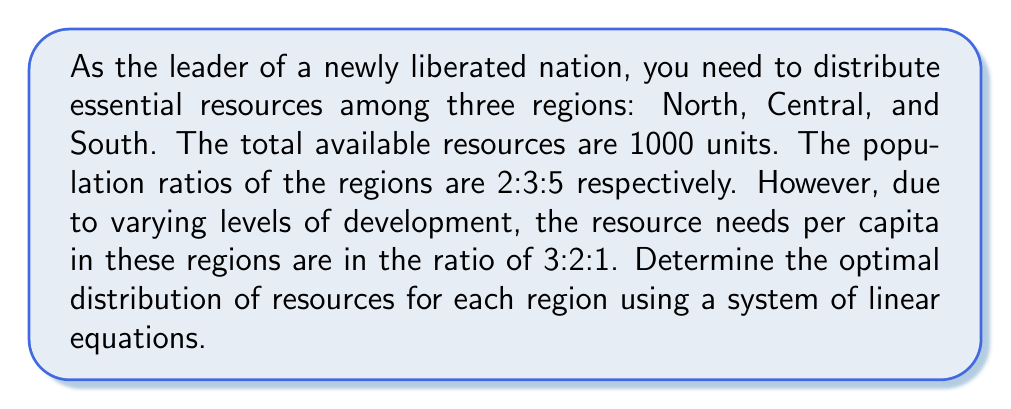Teach me how to tackle this problem. Let's approach this step-by-step:

1) Let $x$, $y$, and $z$ be the resources allocated to North, Central, and South regions respectively.

2) Given the total resources, we can write our first equation:
   $$x + y + z = 1000$$ (Equation 1)

3) The population ratios are 2:3:5, and the per capita needs are 3:2:1. To find the optimal distribution, we need to equalize the resources per capita adjusted for needs:

   For North: $\frac{x}{2} \cdot \frac{1}{3}$
   For Central: $\frac{y}{3} \cdot \frac{1}{2}$
   For South: $\frac{z}{5} \cdot \frac{1}{1}$

4) These should be equal, so we can write:
   $$\frac{x}{6} = \frac{y}{6} = \frac{z}{5}$$ (Equation 2)

5) From Equation 2, we can derive:
   $$x = y$$ (Equation 3)
   $$\frac{x}{6} = \frac{z}{5}$$ or $$5x = 6z$$ (Equation 4)

6) Substituting Equation 3 into Equation 1:
   $$x + x + z = 1000$$
   $$2x + z = 1000$$ (Equation 5)

7) From Equation 4: $x = \frac{6z}{5}$

8) Substituting this into Equation 5:
   $$2(\frac{6z}{5}) + z = 1000$$
   $$\frac{12z}{5} + z = 1000$$
   $$\frac{12z + 5z}{5} = 1000$$
   $$\frac{17z}{5} = 1000$$
   $$17z = 5000$$
   $$z = \frac{5000}{17} \approx 294.12$$

9) Using this value of $z$ in Equation 4:
   $$5x = 6(294.12)$$
   $$x = \frac{6(294.12)}{5} \approx 352.94$$

10) Since $x = y$, we now have all three values.
Answer: North: 353 units, Central: 353 units, South: 294 units 